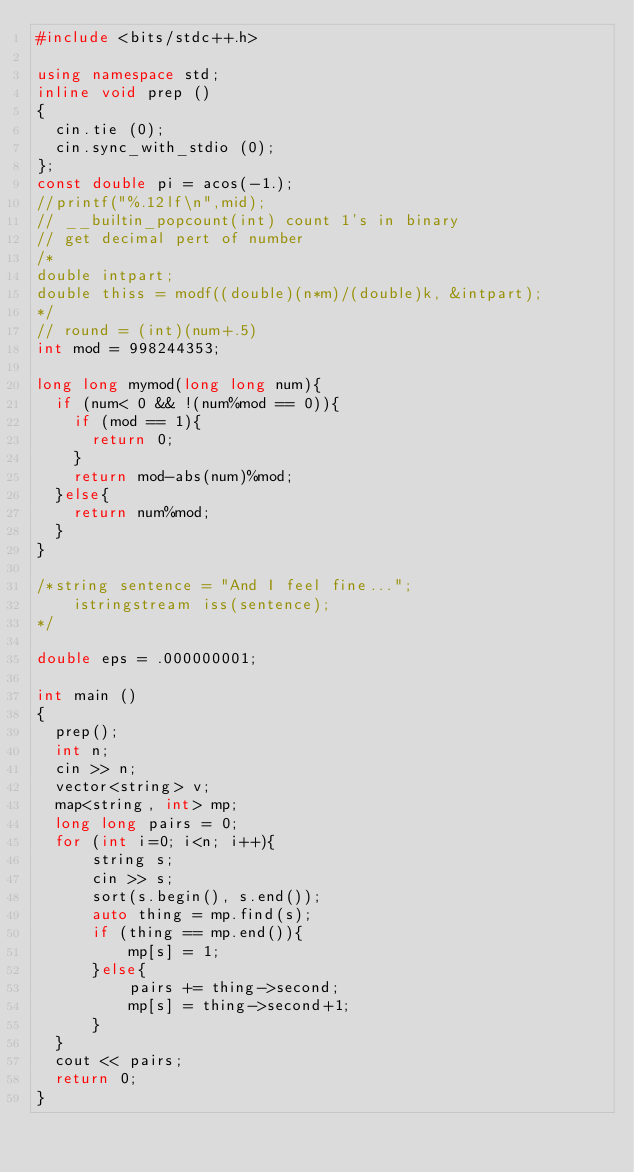<code> <loc_0><loc_0><loc_500><loc_500><_C++_>#include <bits/stdc++.h>

using namespace std;
inline void prep ()
{
  cin.tie (0);
  cin.sync_with_stdio (0);
};
const double pi = acos(-1.);
//printf("%.12lf\n",mid);
// __builtin_popcount(int) count 1's in binary
// get decimal pert of number
/*
double intpart;
double thiss = modf((double)(n*m)/(double)k, &intpart);
*/
// round = (int)(num+.5)
int mod = 998244353;

long long mymod(long long num){
  if (num< 0 && !(num%mod == 0)){
    if (mod == 1){
      return 0;
    }
    return mod-abs(num)%mod;
  }else{
    return num%mod;
  }
}

/*string sentence = "And I feel fine...";
    istringstream iss(sentence);
*/  

double eps = .000000001;

int main ()
{
  prep();
  int n;
  cin >> n;
  vector<string> v;
  map<string, int> mp;
  long long pairs = 0;
  for (int i=0; i<n; i++){
      string s;
      cin >> s;
      sort(s.begin(), s.end());
      auto thing = mp.find(s);
      if (thing == mp.end()){
          mp[s] = 1;
      }else{
          pairs += thing->second;
          mp[s] = thing->second+1;
      }
  }
  cout << pairs;
  return 0; 
}</code> 